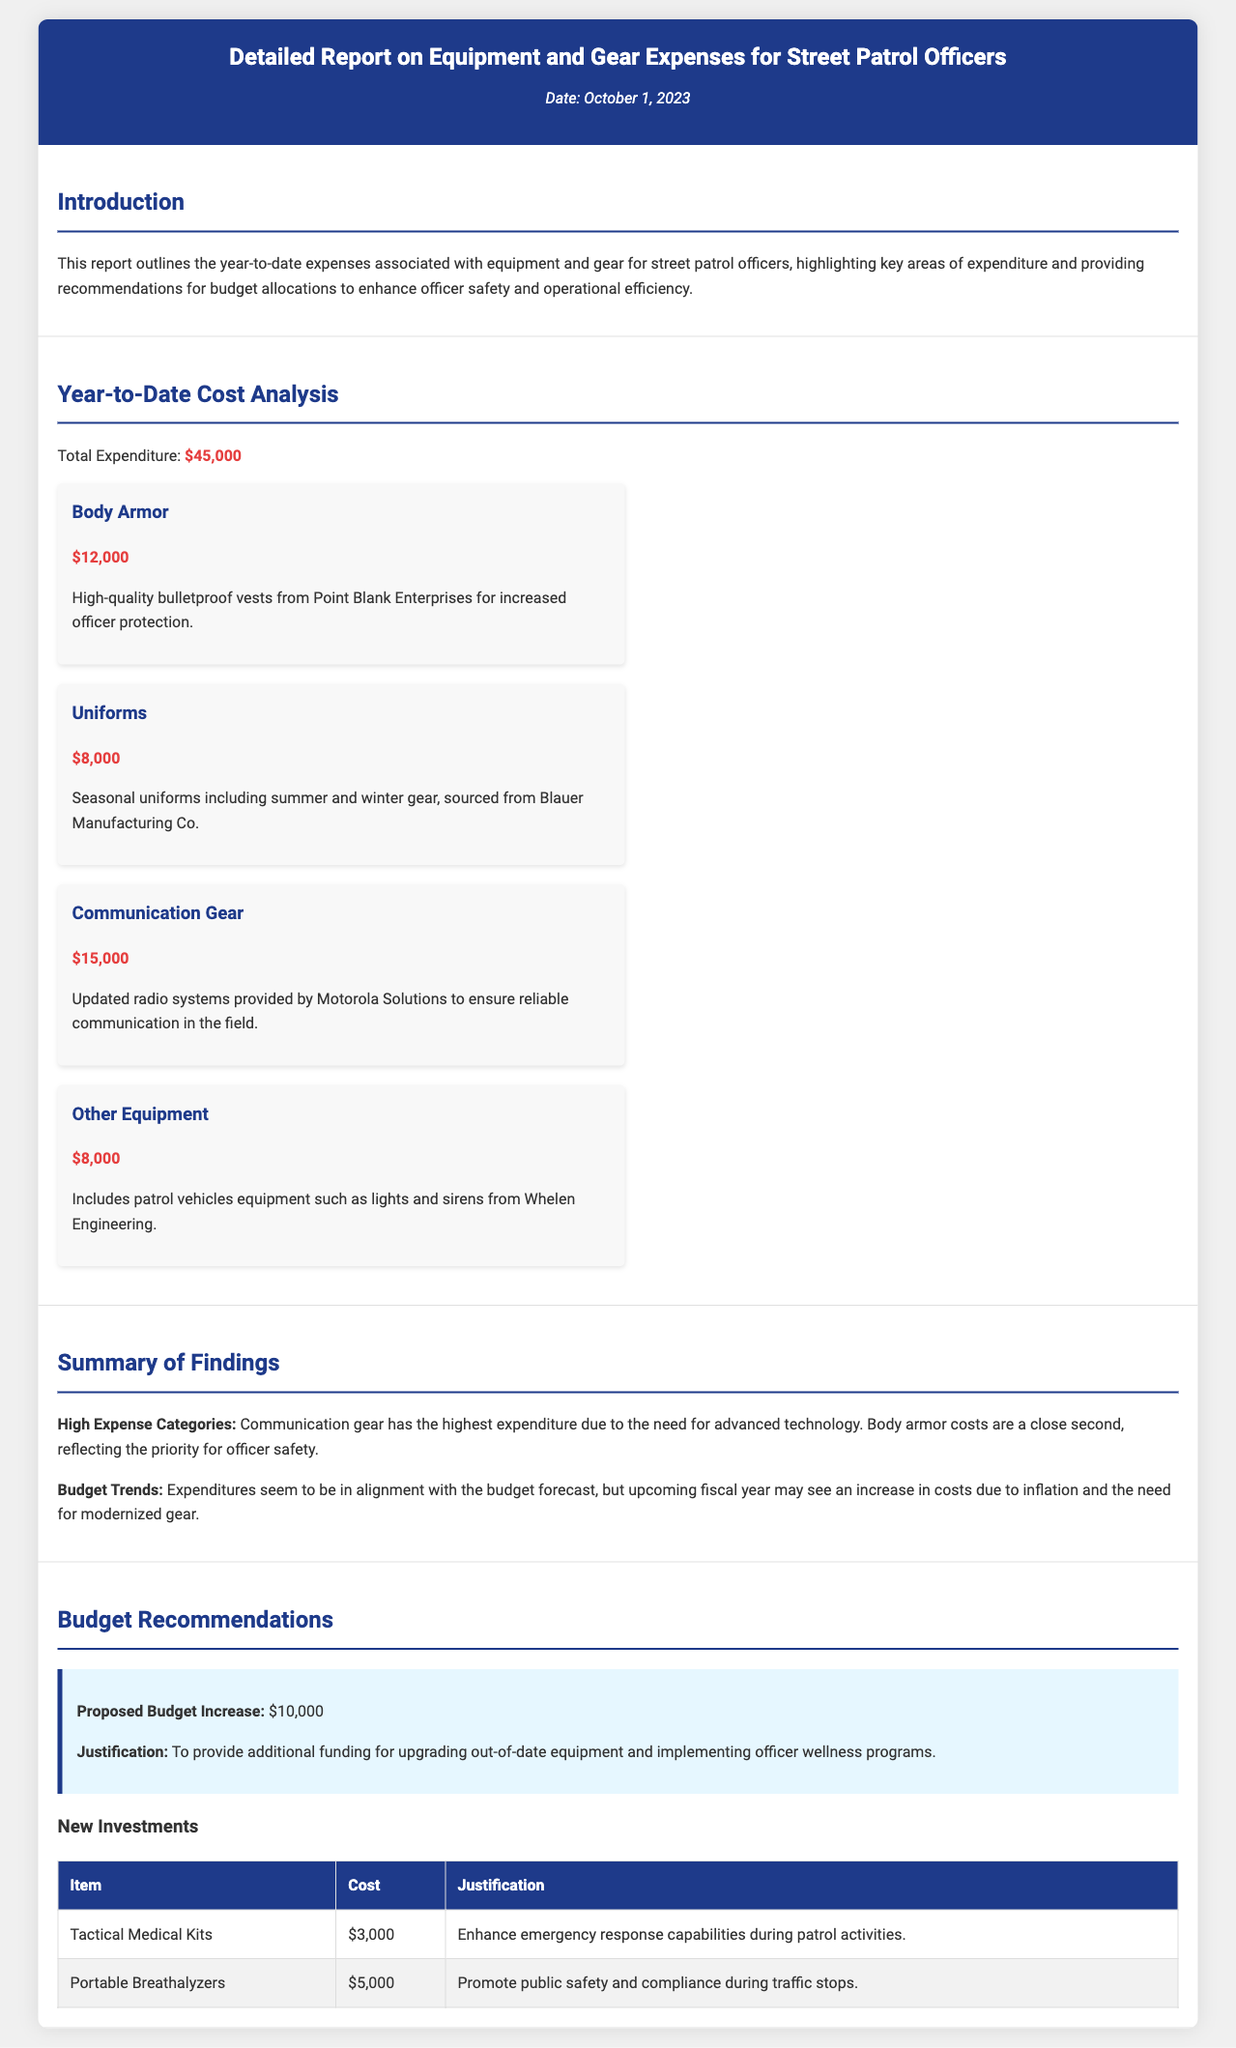What is the total expenditure? The total expenditure is presented in the document as a single amount, which is $45,000.
Answer: $45,000 What is the cost of body armor? The specific cost associated with body armor is detailed in the report, which is $12,000.
Answer: $12,000 Which company provided the communication gear? The company responsible for the provision of communication gear is named in the document as Motorola Solutions.
Answer: Motorola Solutions What is the proposed budget increase? The document explicitly states the proposed budget increase amount and it is $10,000.
Answer: $10,000 What percentage of the total expenditure does uniforms represent? Uniforms cost $8,000, and to find the percentage, we can determine that it is approximately 17.78% of the total expenditure.
Answer: 17.78% How many types of new investments are mentioned? The document lists two types of new investments, which are Tactical Medical Kits and Portable Breathalyzers.
Answer: Two What is the justification for the proposed budget increase? The justification provided for the proposed budget increase is to upgrade out-of-date equipment and implement officer wellness programs.
Answer: Upgrade equipment and wellness programs What category of expense has the highest cost? The category that has the highest cost among the listed expenses is Communication Gear.
Answer: Communication Gear Which item costs the least among the new investments? The least expensive item listed among the new investments is Tactical Medical Kits, which costs $3,000.
Answer: $3,000 